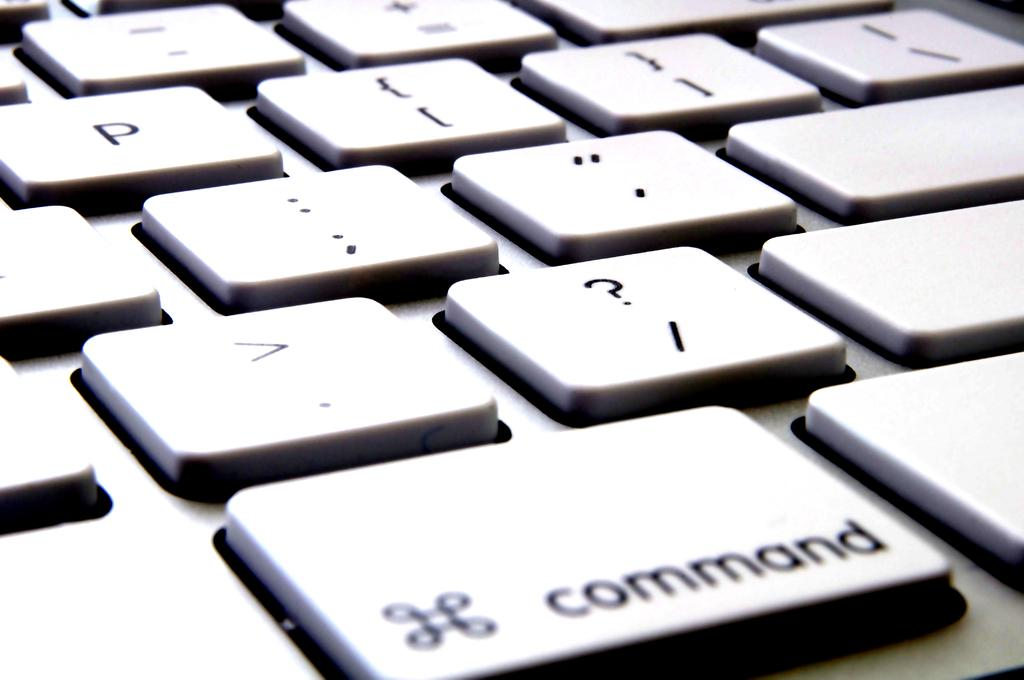<image>
Offer a succinct explanation of the picture presented. Keyboard with letters, symbols, and command buttons on the board 